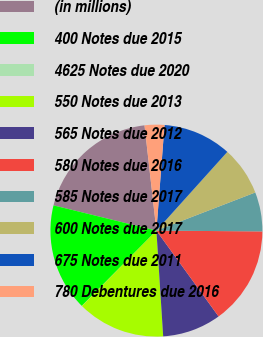<chart> <loc_0><loc_0><loc_500><loc_500><pie_chart><fcel>(in millions)<fcel>400 Notes due 2015<fcel>4625 Notes due 2020<fcel>550 Notes due 2013<fcel>565 Notes due 2012<fcel>580 Notes due 2016<fcel>585 Notes due 2017<fcel>600 Notes due 2017<fcel>675 Notes due 2011<fcel>780 Debentures due 2016<nl><fcel>19.38%<fcel>16.4%<fcel>0.03%<fcel>13.42%<fcel>8.96%<fcel>14.91%<fcel>5.98%<fcel>7.47%<fcel>10.45%<fcel>3.01%<nl></chart> 